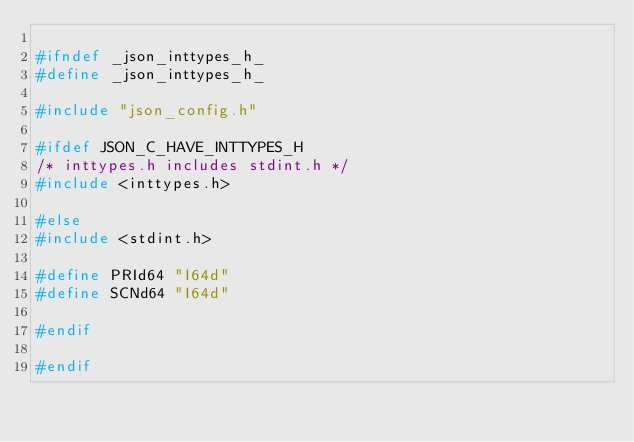Convert code to text. <code><loc_0><loc_0><loc_500><loc_500><_C_>
#ifndef _json_inttypes_h_
#define _json_inttypes_h_

#include "json_config.h"

#ifdef JSON_C_HAVE_INTTYPES_H
/* inttypes.h includes stdint.h */
#include <inttypes.h>

#else
#include <stdint.h>

#define PRId64 "I64d"
#define SCNd64 "I64d"

#endif

#endif
</code> 